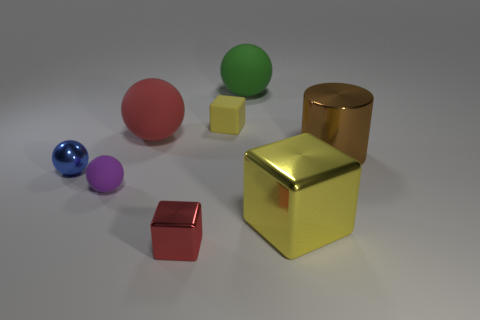Subtract all small cubes. How many cubes are left? 1 Subtract all cyan spheres. How many yellow blocks are left? 2 Subtract 2 balls. How many balls are left? 2 Subtract all blue spheres. How many spheres are left? 3 Subtract all yellow spheres. Subtract all blue cubes. How many spheres are left? 4 Add 2 tiny purple spheres. How many objects exist? 10 Subtract all cylinders. How many objects are left? 7 Add 4 tiny purple matte spheres. How many tiny purple matte spheres are left? 5 Add 1 red spheres. How many red spheres exist? 2 Subtract 1 blue spheres. How many objects are left? 7 